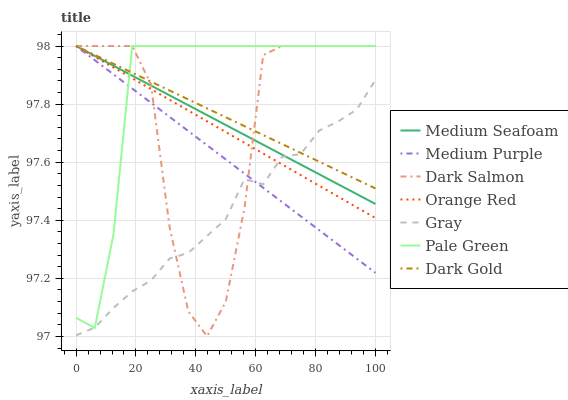Does Gray have the minimum area under the curve?
Answer yes or no. Yes. Does Pale Green have the maximum area under the curve?
Answer yes or no. Yes. Does Dark Gold have the minimum area under the curve?
Answer yes or no. No. Does Dark Gold have the maximum area under the curve?
Answer yes or no. No. Is Orange Red the smoothest?
Answer yes or no. Yes. Is Dark Salmon the roughest?
Answer yes or no. Yes. Is Dark Gold the smoothest?
Answer yes or no. No. Is Dark Gold the roughest?
Answer yes or no. No. Does Dark Gold have the lowest value?
Answer yes or no. No. Does Medium Seafoam have the highest value?
Answer yes or no. Yes. Does Medium Purple intersect Orange Red?
Answer yes or no. Yes. Is Medium Purple less than Orange Red?
Answer yes or no. No. Is Medium Purple greater than Orange Red?
Answer yes or no. No. 